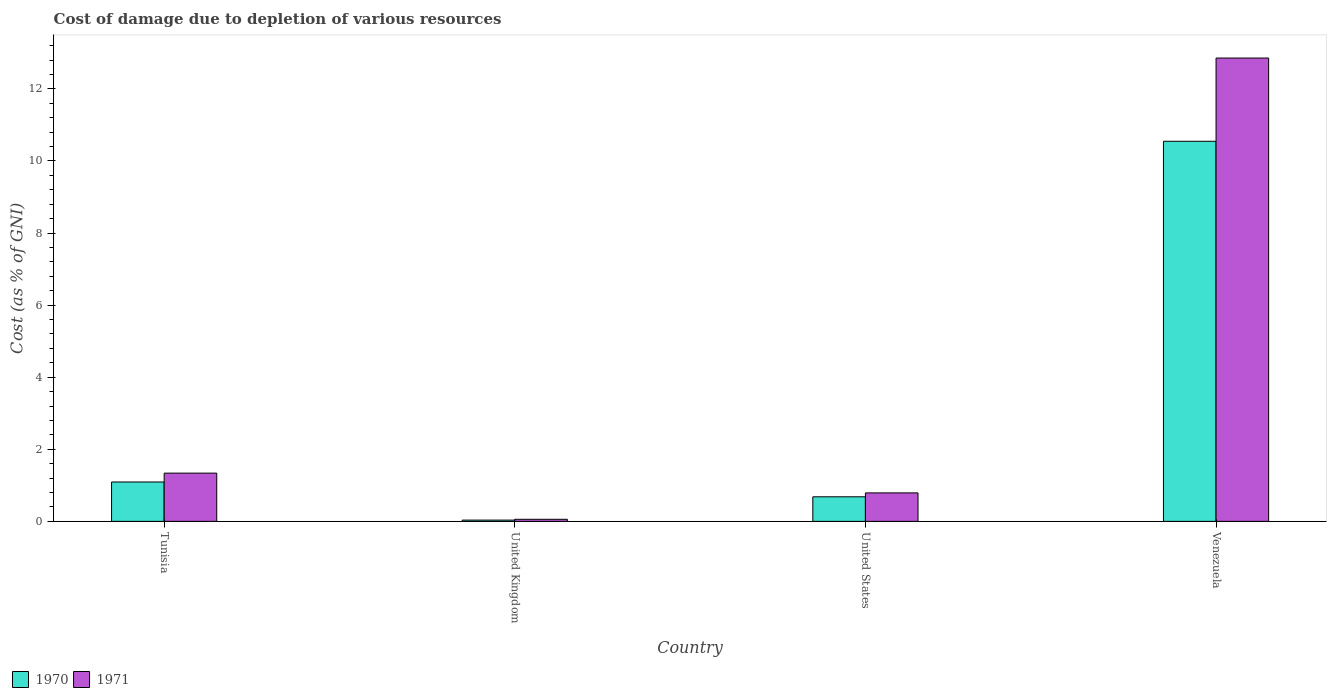How many bars are there on the 4th tick from the left?
Ensure brevity in your answer.  2. How many bars are there on the 1st tick from the right?
Offer a very short reply. 2. What is the label of the 1st group of bars from the left?
Make the answer very short. Tunisia. In how many cases, is the number of bars for a given country not equal to the number of legend labels?
Offer a very short reply. 0. What is the cost of damage caused due to the depletion of various resources in 1971 in United Kingdom?
Ensure brevity in your answer.  0.06. Across all countries, what is the maximum cost of damage caused due to the depletion of various resources in 1971?
Ensure brevity in your answer.  12.86. Across all countries, what is the minimum cost of damage caused due to the depletion of various resources in 1971?
Your answer should be compact. 0.06. In which country was the cost of damage caused due to the depletion of various resources in 1971 maximum?
Offer a terse response. Venezuela. What is the total cost of damage caused due to the depletion of various resources in 1971 in the graph?
Make the answer very short. 15.04. What is the difference between the cost of damage caused due to the depletion of various resources in 1970 in United Kingdom and that in United States?
Offer a terse response. -0.65. What is the difference between the cost of damage caused due to the depletion of various resources in 1971 in United States and the cost of damage caused due to the depletion of various resources in 1970 in United Kingdom?
Your response must be concise. 0.75. What is the average cost of damage caused due to the depletion of various resources in 1971 per country?
Your answer should be very brief. 3.76. What is the difference between the cost of damage caused due to the depletion of various resources of/in 1971 and cost of damage caused due to the depletion of various resources of/in 1970 in United States?
Offer a terse response. 0.11. In how many countries, is the cost of damage caused due to the depletion of various resources in 1970 greater than 6.8 %?
Provide a succinct answer. 1. What is the ratio of the cost of damage caused due to the depletion of various resources in 1970 in United Kingdom to that in United States?
Your answer should be very brief. 0.05. Is the cost of damage caused due to the depletion of various resources in 1971 in Tunisia less than that in United Kingdom?
Your answer should be compact. No. What is the difference between the highest and the second highest cost of damage caused due to the depletion of various resources in 1970?
Your answer should be compact. -0.41. What is the difference between the highest and the lowest cost of damage caused due to the depletion of various resources in 1970?
Keep it short and to the point. 10.51. In how many countries, is the cost of damage caused due to the depletion of various resources in 1970 greater than the average cost of damage caused due to the depletion of various resources in 1970 taken over all countries?
Provide a short and direct response. 1. Is the sum of the cost of damage caused due to the depletion of various resources in 1971 in United Kingdom and Venezuela greater than the maximum cost of damage caused due to the depletion of various resources in 1970 across all countries?
Provide a succinct answer. Yes. How many bars are there?
Provide a short and direct response. 8. Are all the bars in the graph horizontal?
Keep it short and to the point. No. How many countries are there in the graph?
Your answer should be compact. 4. What is the difference between two consecutive major ticks on the Y-axis?
Offer a terse response. 2. Are the values on the major ticks of Y-axis written in scientific E-notation?
Your answer should be compact. No. Does the graph contain any zero values?
Your answer should be very brief. No. Does the graph contain grids?
Ensure brevity in your answer.  No. Where does the legend appear in the graph?
Give a very brief answer. Bottom left. What is the title of the graph?
Provide a succinct answer. Cost of damage due to depletion of various resources. What is the label or title of the X-axis?
Your answer should be very brief. Country. What is the label or title of the Y-axis?
Keep it short and to the point. Cost (as % of GNI). What is the Cost (as % of GNI) in 1970 in Tunisia?
Your answer should be compact. 1.09. What is the Cost (as % of GNI) of 1971 in Tunisia?
Ensure brevity in your answer.  1.34. What is the Cost (as % of GNI) of 1970 in United Kingdom?
Your answer should be very brief. 0.03. What is the Cost (as % of GNI) in 1971 in United Kingdom?
Provide a succinct answer. 0.06. What is the Cost (as % of GNI) in 1970 in United States?
Your response must be concise. 0.68. What is the Cost (as % of GNI) of 1971 in United States?
Your response must be concise. 0.79. What is the Cost (as % of GNI) of 1970 in Venezuela?
Provide a succinct answer. 10.55. What is the Cost (as % of GNI) in 1971 in Venezuela?
Offer a very short reply. 12.86. Across all countries, what is the maximum Cost (as % of GNI) in 1970?
Your answer should be compact. 10.55. Across all countries, what is the maximum Cost (as % of GNI) in 1971?
Offer a terse response. 12.86. Across all countries, what is the minimum Cost (as % of GNI) in 1970?
Give a very brief answer. 0.03. Across all countries, what is the minimum Cost (as % of GNI) in 1971?
Give a very brief answer. 0.06. What is the total Cost (as % of GNI) of 1970 in the graph?
Offer a very short reply. 12.36. What is the total Cost (as % of GNI) in 1971 in the graph?
Provide a succinct answer. 15.04. What is the difference between the Cost (as % of GNI) of 1970 in Tunisia and that in United Kingdom?
Your response must be concise. 1.06. What is the difference between the Cost (as % of GNI) in 1971 in Tunisia and that in United Kingdom?
Your answer should be compact. 1.28. What is the difference between the Cost (as % of GNI) of 1970 in Tunisia and that in United States?
Make the answer very short. 0.41. What is the difference between the Cost (as % of GNI) of 1971 in Tunisia and that in United States?
Offer a very short reply. 0.55. What is the difference between the Cost (as % of GNI) of 1970 in Tunisia and that in Venezuela?
Your response must be concise. -9.45. What is the difference between the Cost (as % of GNI) in 1971 in Tunisia and that in Venezuela?
Give a very brief answer. -11.52. What is the difference between the Cost (as % of GNI) in 1970 in United Kingdom and that in United States?
Provide a short and direct response. -0.65. What is the difference between the Cost (as % of GNI) of 1971 in United Kingdom and that in United States?
Ensure brevity in your answer.  -0.73. What is the difference between the Cost (as % of GNI) in 1970 in United Kingdom and that in Venezuela?
Ensure brevity in your answer.  -10.51. What is the difference between the Cost (as % of GNI) of 1971 in United Kingdom and that in Venezuela?
Give a very brief answer. -12.8. What is the difference between the Cost (as % of GNI) of 1970 in United States and that in Venezuela?
Make the answer very short. -9.86. What is the difference between the Cost (as % of GNI) in 1971 in United States and that in Venezuela?
Give a very brief answer. -12.07. What is the difference between the Cost (as % of GNI) of 1970 in Tunisia and the Cost (as % of GNI) of 1971 in United Kingdom?
Offer a very short reply. 1.03. What is the difference between the Cost (as % of GNI) of 1970 in Tunisia and the Cost (as % of GNI) of 1971 in United States?
Offer a very short reply. 0.3. What is the difference between the Cost (as % of GNI) in 1970 in Tunisia and the Cost (as % of GNI) in 1971 in Venezuela?
Give a very brief answer. -11.76. What is the difference between the Cost (as % of GNI) in 1970 in United Kingdom and the Cost (as % of GNI) in 1971 in United States?
Ensure brevity in your answer.  -0.76. What is the difference between the Cost (as % of GNI) in 1970 in United Kingdom and the Cost (as % of GNI) in 1971 in Venezuela?
Your answer should be compact. -12.82. What is the difference between the Cost (as % of GNI) in 1970 in United States and the Cost (as % of GNI) in 1971 in Venezuela?
Make the answer very short. -12.17. What is the average Cost (as % of GNI) in 1970 per country?
Ensure brevity in your answer.  3.09. What is the average Cost (as % of GNI) of 1971 per country?
Your answer should be very brief. 3.76. What is the difference between the Cost (as % of GNI) of 1970 and Cost (as % of GNI) of 1971 in Tunisia?
Offer a very short reply. -0.25. What is the difference between the Cost (as % of GNI) in 1970 and Cost (as % of GNI) in 1971 in United Kingdom?
Your answer should be compact. -0.02. What is the difference between the Cost (as % of GNI) of 1970 and Cost (as % of GNI) of 1971 in United States?
Offer a terse response. -0.11. What is the difference between the Cost (as % of GNI) in 1970 and Cost (as % of GNI) in 1971 in Venezuela?
Make the answer very short. -2.31. What is the ratio of the Cost (as % of GNI) of 1970 in Tunisia to that in United Kingdom?
Keep it short and to the point. 31.3. What is the ratio of the Cost (as % of GNI) of 1971 in Tunisia to that in United Kingdom?
Ensure brevity in your answer.  23.24. What is the ratio of the Cost (as % of GNI) in 1970 in Tunisia to that in United States?
Ensure brevity in your answer.  1.6. What is the ratio of the Cost (as % of GNI) of 1971 in Tunisia to that in United States?
Your answer should be very brief. 1.69. What is the ratio of the Cost (as % of GNI) in 1970 in Tunisia to that in Venezuela?
Your answer should be very brief. 0.1. What is the ratio of the Cost (as % of GNI) in 1971 in Tunisia to that in Venezuela?
Give a very brief answer. 0.1. What is the ratio of the Cost (as % of GNI) in 1970 in United Kingdom to that in United States?
Your answer should be compact. 0.05. What is the ratio of the Cost (as % of GNI) of 1971 in United Kingdom to that in United States?
Keep it short and to the point. 0.07. What is the ratio of the Cost (as % of GNI) in 1970 in United Kingdom to that in Venezuela?
Ensure brevity in your answer.  0. What is the ratio of the Cost (as % of GNI) in 1971 in United Kingdom to that in Venezuela?
Offer a terse response. 0. What is the ratio of the Cost (as % of GNI) of 1970 in United States to that in Venezuela?
Offer a very short reply. 0.06. What is the ratio of the Cost (as % of GNI) in 1971 in United States to that in Venezuela?
Give a very brief answer. 0.06. What is the difference between the highest and the second highest Cost (as % of GNI) of 1970?
Ensure brevity in your answer.  9.45. What is the difference between the highest and the second highest Cost (as % of GNI) of 1971?
Make the answer very short. 11.52. What is the difference between the highest and the lowest Cost (as % of GNI) in 1970?
Give a very brief answer. 10.51. What is the difference between the highest and the lowest Cost (as % of GNI) in 1971?
Make the answer very short. 12.8. 